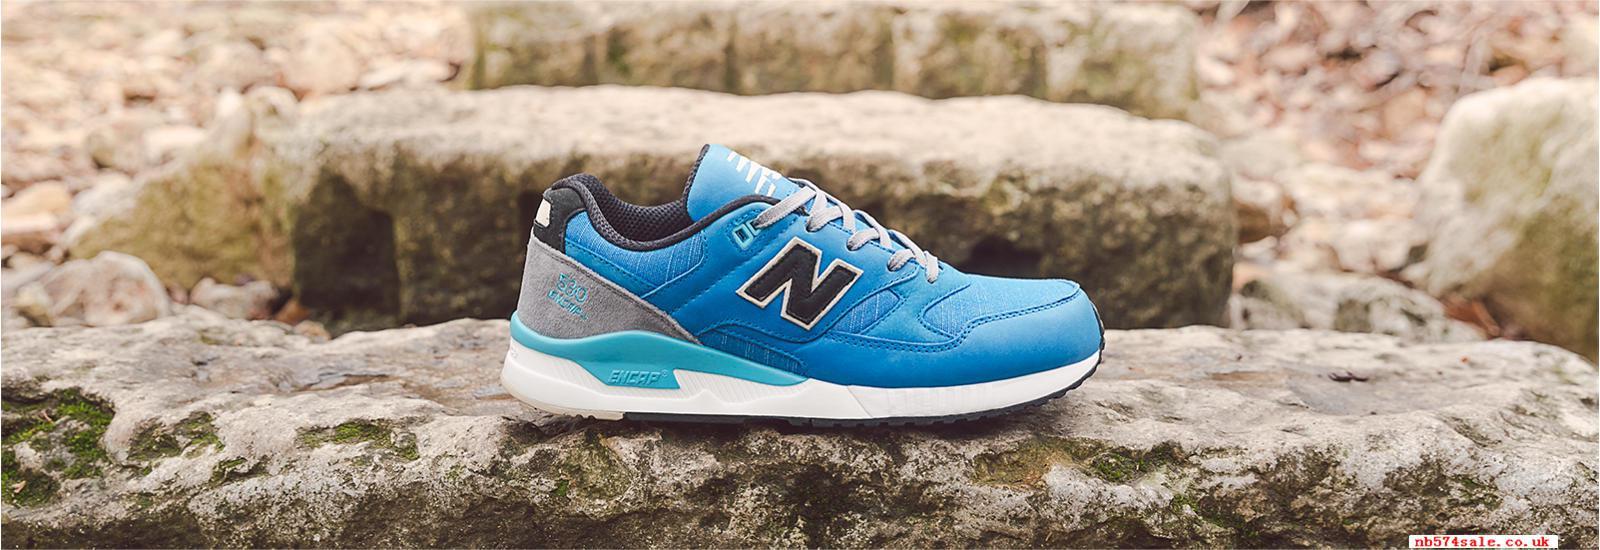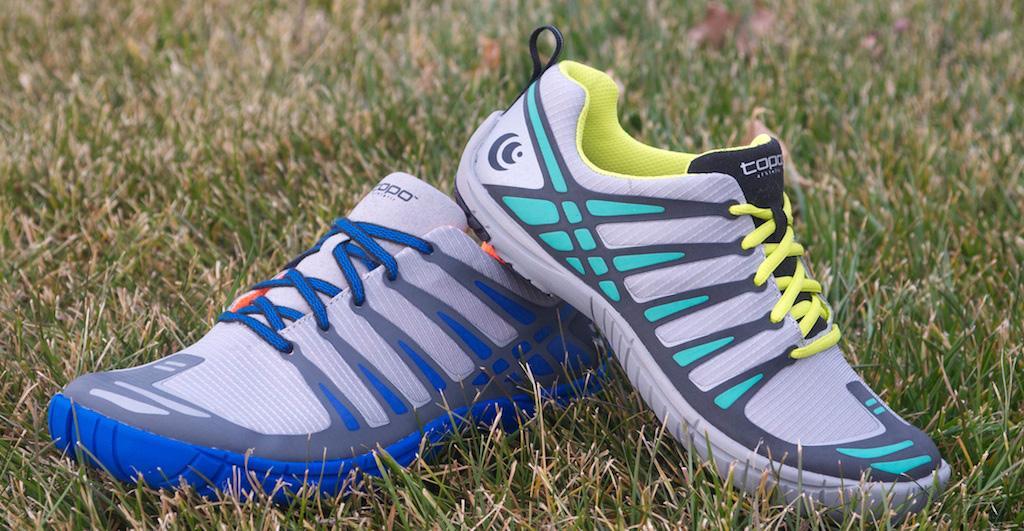The first image is the image on the left, the second image is the image on the right. Evaluate the accuracy of this statement regarding the images: "An image shows a single, predominantly blue shoe in profile.". Is it true? Answer yes or no. Yes. 